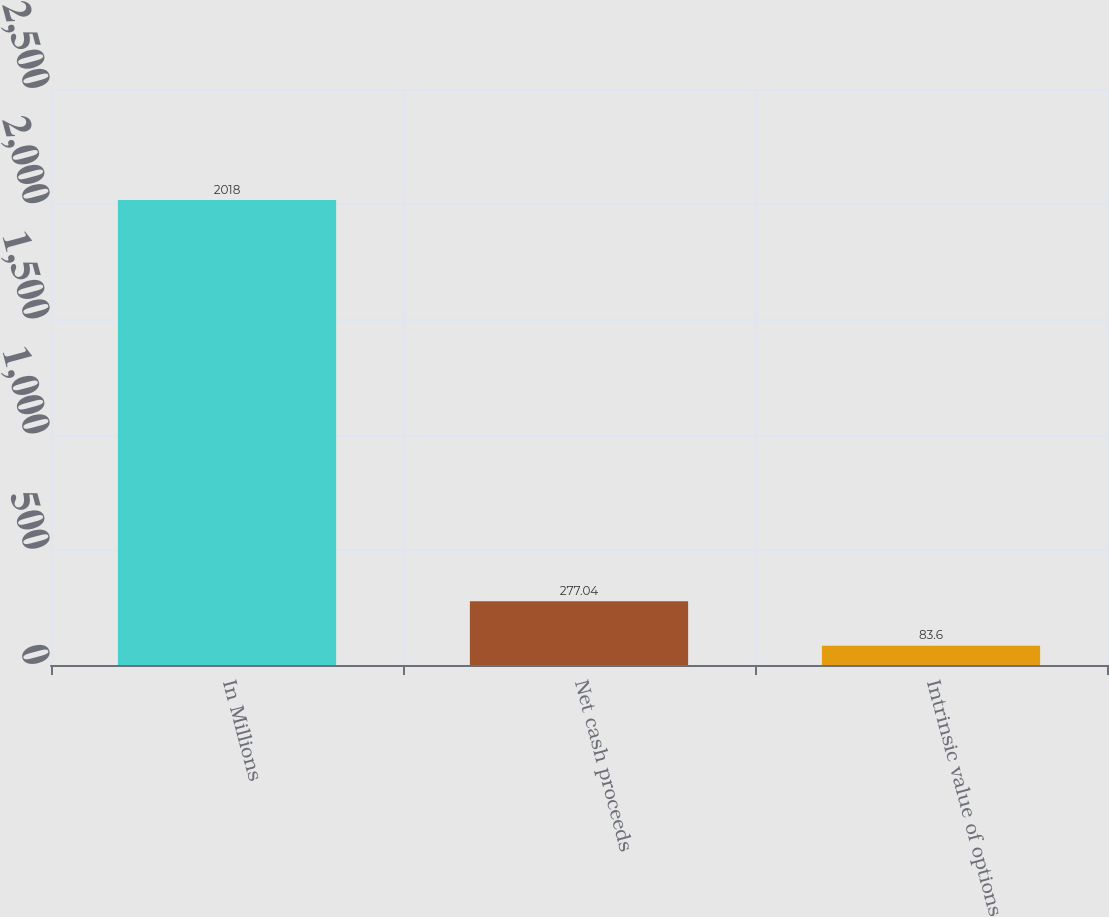Convert chart. <chart><loc_0><loc_0><loc_500><loc_500><bar_chart><fcel>In Millions<fcel>Net cash proceeds<fcel>Intrinsic value of options<nl><fcel>2018<fcel>277.04<fcel>83.6<nl></chart> 